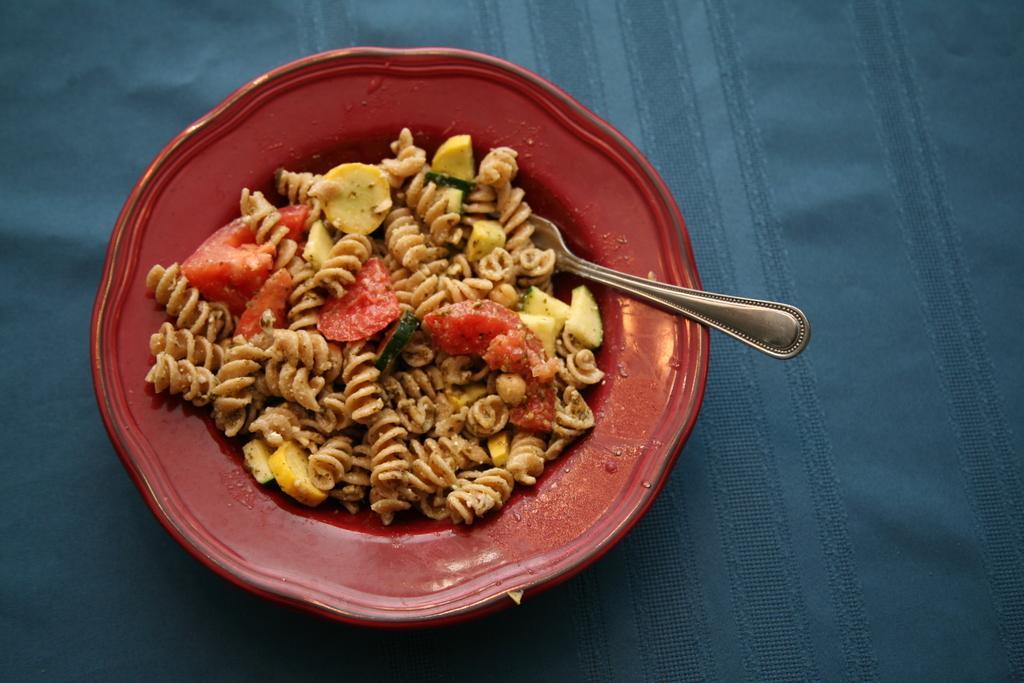In one or two sentences, can you explain what this image depicts? In this image there are food items and a spoon in a bowl which was placed on the blue color cloth. 